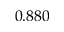<formula> <loc_0><loc_0><loc_500><loc_500>0 . 8 8 0</formula> 